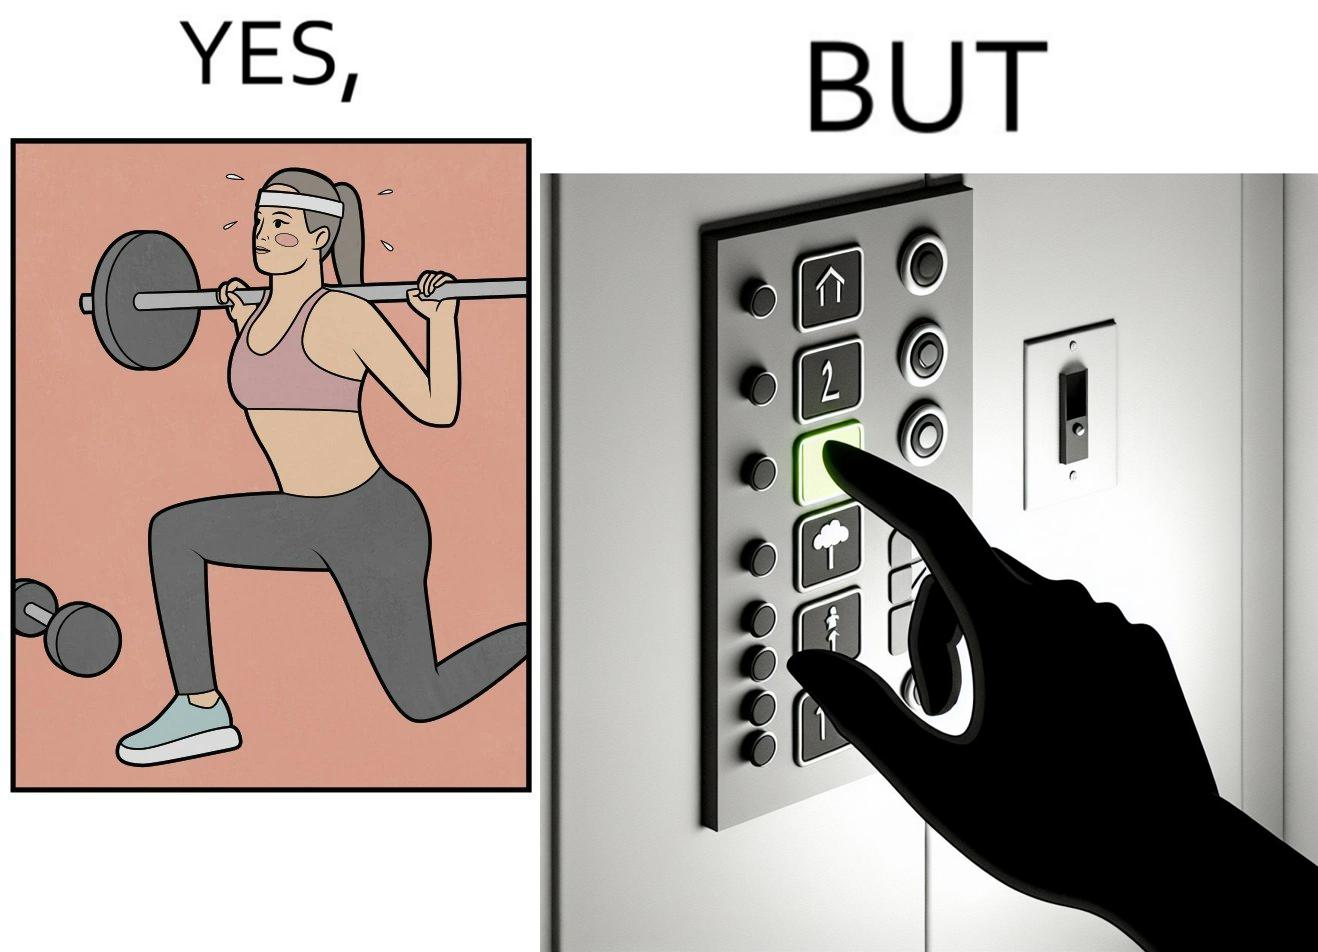Would you classify this image as satirical? Yes, this image is satirical. 